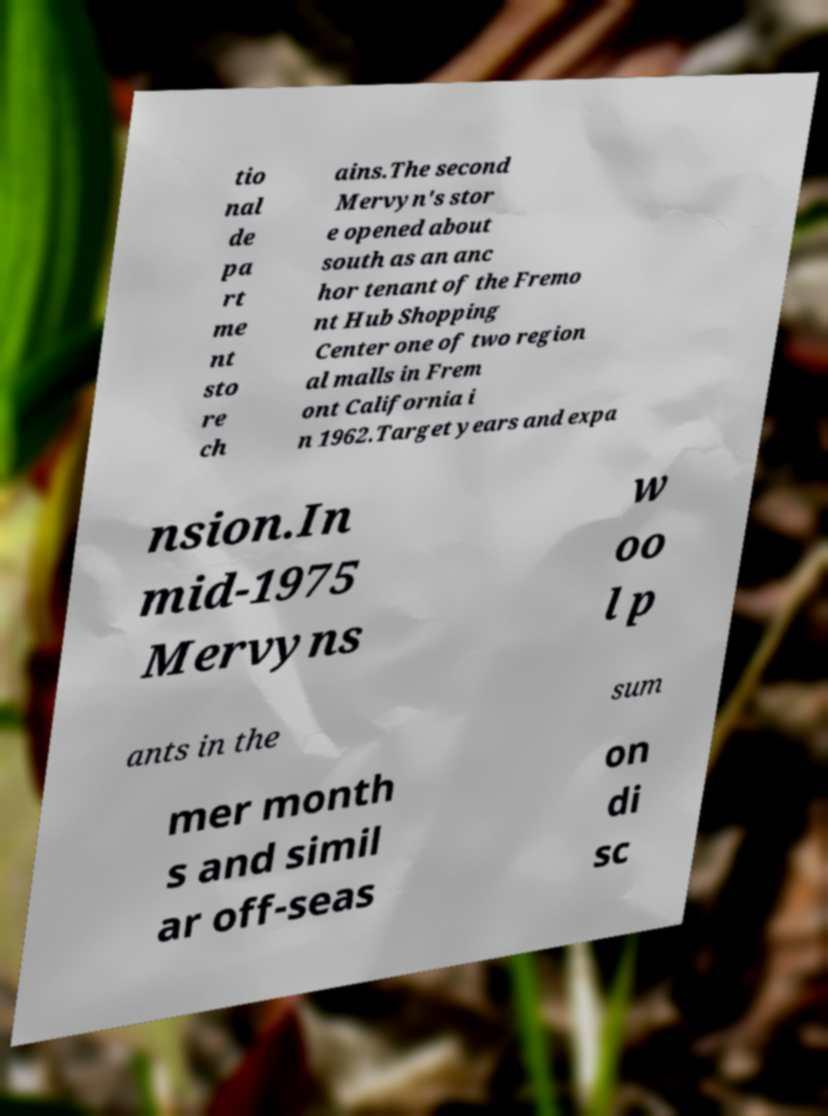Can you read and provide the text displayed in the image?This photo seems to have some interesting text. Can you extract and type it out for me? tio nal de pa rt me nt sto re ch ains.The second Mervyn's stor e opened about south as an anc hor tenant of the Fremo nt Hub Shopping Center one of two region al malls in Frem ont California i n 1962.Target years and expa nsion.In mid-1975 Mervyns w oo l p ants in the sum mer month s and simil ar off-seas on di sc 